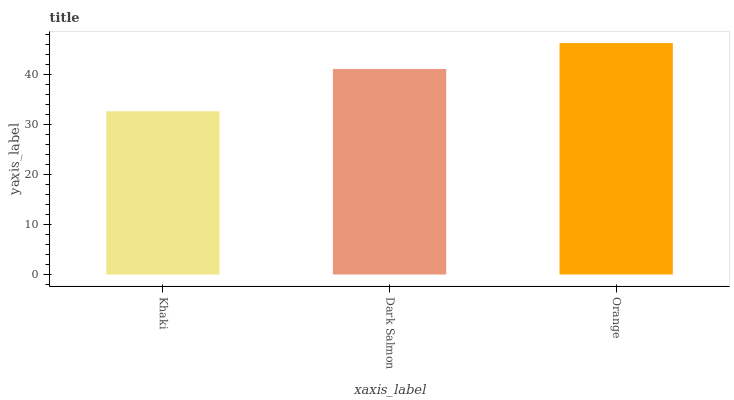Is Khaki the minimum?
Answer yes or no. Yes. Is Orange the maximum?
Answer yes or no. Yes. Is Dark Salmon the minimum?
Answer yes or no. No. Is Dark Salmon the maximum?
Answer yes or no. No. Is Dark Salmon greater than Khaki?
Answer yes or no. Yes. Is Khaki less than Dark Salmon?
Answer yes or no. Yes. Is Khaki greater than Dark Salmon?
Answer yes or no. No. Is Dark Salmon less than Khaki?
Answer yes or no. No. Is Dark Salmon the high median?
Answer yes or no. Yes. Is Dark Salmon the low median?
Answer yes or no. Yes. Is Khaki the high median?
Answer yes or no. No. Is Orange the low median?
Answer yes or no. No. 